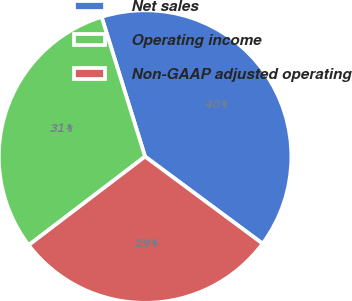<chart> <loc_0><loc_0><loc_500><loc_500><pie_chart><fcel>Net sales<fcel>Operating income<fcel>Non-GAAP adjusted operating<nl><fcel>39.95%<fcel>30.55%<fcel>29.5%<nl></chart> 